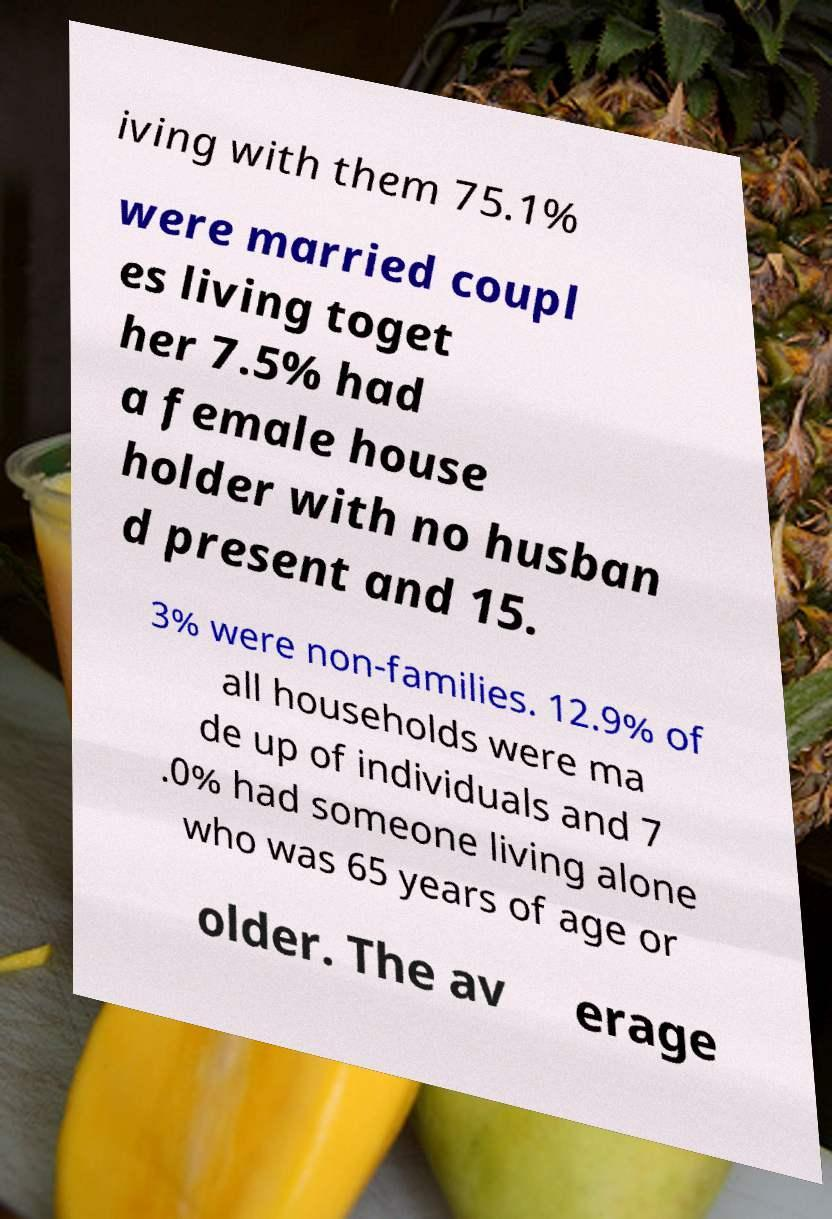Could you assist in decoding the text presented in this image and type it out clearly? iving with them 75.1% were married coupl es living toget her 7.5% had a female house holder with no husban d present and 15. 3% were non-families. 12.9% of all households were ma de up of individuals and 7 .0% had someone living alone who was 65 years of age or older. The av erage 